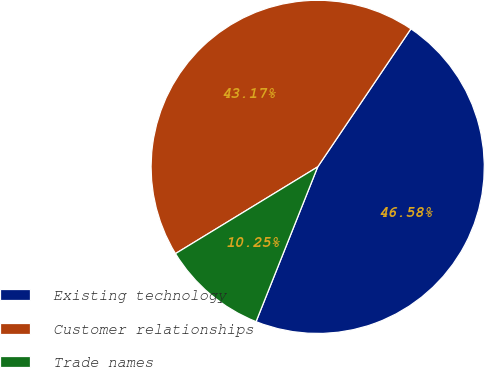Convert chart to OTSL. <chart><loc_0><loc_0><loc_500><loc_500><pie_chart><fcel>Existing technology<fcel>Customer relationships<fcel>Trade names<nl><fcel>46.58%<fcel>43.17%<fcel>10.25%<nl></chart> 